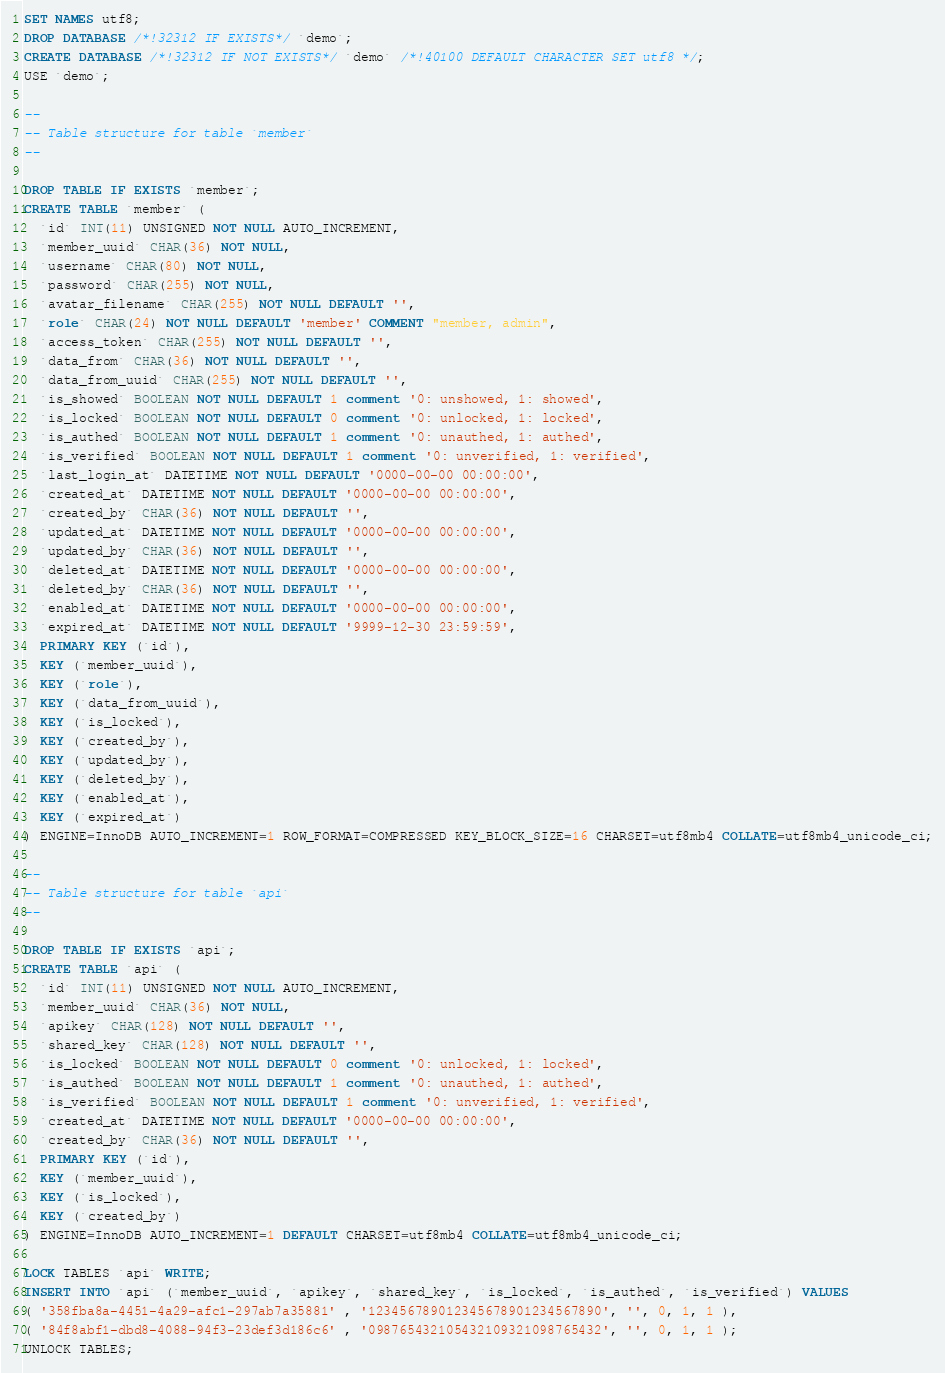Convert code to text. <code><loc_0><loc_0><loc_500><loc_500><_SQL_>SET NAMES utf8;
DROP DATABASE /*!32312 IF EXISTS*/ `demo`;
CREATE DATABASE /*!32312 IF NOT EXISTS*/ `demo` /*!40100 DEFAULT CHARACTER SET utf8 */;
USE `demo`;

--
-- Table structure for table `member`
--

DROP TABLE IF EXISTS `member`;
CREATE TABLE `member` (
  `id` INT(11) UNSIGNED NOT NULL AUTO_INCREMENT,
  `member_uuid` CHAR(36) NOT NULL,
  `username` CHAR(80) NOT NULL,
  `password` CHAR(255) NOT NULL,
  `avatar_filename` CHAR(255) NOT NULL DEFAULT '',
  `role` CHAR(24) NOT NULL DEFAULT 'member' COMMENT "member, admin",
  `access_token` CHAR(255) NOT NULL DEFAULT '',
  `data_from` CHAR(36) NOT NULL DEFAULT '',
  `data_from_uuid` CHAR(255) NOT NULL DEFAULT '',
  `is_showed` BOOLEAN NOT NULL DEFAULT 1 comment '0: unshowed, 1: showed',
  `is_locked` BOOLEAN NOT NULL DEFAULT 0 comment '0: unlocked, 1: locked',
  `is_authed` BOOLEAN NOT NULL DEFAULT 1 comment '0: unauthed, 1: authed',
  `is_verified` BOOLEAN NOT NULL DEFAULT 1 comment '0: unverified, 1: verified',
  `last_login_at` DATETIME NOT NULL DEFAULT '0000-00-00 00:00:00',
  `created_at` DATETIME NOT NULL DEFAULT '0000-00-00 00:00:00',
  `created_by` CHAR(36) NOT NULL DEFAULT '',
  `updated_at` DATETIME NOT NULL DEFAULT '0000-00-00 00:00:00',
  `updated_by` CHAR(36) NOT NULL DEFAULT '',
  `deleted_at` DATETIME NOT NULL DEFAULT '0000-00-00 00:00:00',
  `deleted_by` CHAR(36) NOT NULL DEFAULT '',
  `enabled_at` DATETIME NOT NULL DEFAULT '0000-00-00 00:00:00',
  `expired_at` DATETIME NOT NULL DEFAULT '9999-12-30 23:59:59',
  PRIMARY KEY (`id`),
  KEY (`member_uuid`),
  KEY (`role`),
  KEY (`data_from_uuid`),
  KEY (`is_locked`),
  KEY (`created_by`),
  KEY (`updated_by`),
  KEY (`deleted_by`),
  KEY (`enabled_at`),
  KEY (`expired_at`)
) ENGINE=InnoDB AUTO_INCREMENT=1 ROW_FORMAT=COMPRESSED KEY_BLOCK_SIZE=16 CHARSET=utf8mb4 COLLATE=utf8mb4_unicode_ci;

--
-- Table structure for table `api`
--

DROP TABLE IF EXISTS `api`;
CREATE TABLE `api` (
  `id` INT(11) UNSIGNED NOT NULL AUTO_INCREMENT,
  `member_uuid` CHAR(36) NOT NULL,
  `apikey` CHAR(128) NOT NULL DEFAULT '',
  `shared_key` CHAR(128) NOT NULL DEFAULT '',
  `is_locked` BOOLEAN NOT NULL DEFAULT 0 comment '0: unlocked, 1: locked',
  `is_authed` BOOLEAN NOT NULL DEFAULT 1 comment '0: unauthed, 1: authed',
  `is_verified` BOOLEAN NOT NULL DEFAULT 1 comment '0: unverified, 1: verified',
  `created_at` DATETIME NOT NULL DEFAULT '0000-00-00 00:00:00',
  `created_by` CHAR(36) NOT NULL DEFAULT '',
  PRIMARY KEY (`id`),
  KEY (`member_uuid`),
  KEY (`is_locked`),
  KEY (`created_by`)
) ENGINE=InnoDB AUTO_INCREMENT=1 DEFAULT CHARSET=utf8mb4 COLLATE=utf8mb4_unicode_ci;

LOCK TABLES `api` WRITE;
INSERT INTO `api` (`member_uuid`, `apikey`, `shared_key`, `is_locked`, `is_authed`, `is_verified`) VALUES
( '358fba8a-4451-4a29-afc1-297ab7a35881' , '123456789012345678901234567890', '', 0, 1, 1 ),
( '84f8abf1-dbd8-4088-94f3-23def3d186c6' , '098765432105432109321098765432', '', 0, 1, 1 );
UNLOCK TABLES;

</code> 